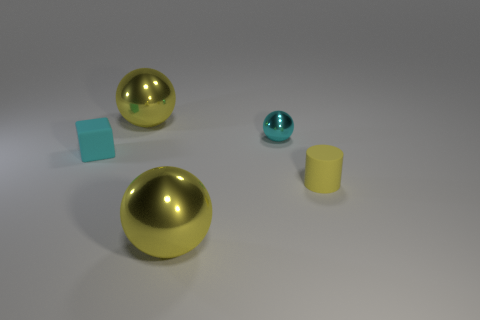Does the small cyan thing right of the tiny cyan matte object have the same shape as the big yellow object that is in front of the tiny cyan matte block?
Offer a very short reply. Yes. How many matte objects are the same color as the tiny metal thing?
Offer a very short reply. 1. What shape is the small object that is left of the large yellow sphere behind the cyan block?
Make the answer very short. Cube. What number of brown objects are either small matte cylinders or matte cubes?
Make the answer very short. 0. What color is the small metal ball?
Your response must be concise. Cyan. Does the cube have the same size as the yellow cylinder?
Your response must be concise. Yes. Is there anything else that is the same shape as the tiny yellow object?
Your response must be concise. No. Is the tiny cube made of the same material as the big yellow sphere behind the rubber cylinder?
Provide a succinct answer. No. There is a large sphere that is behind the tiny matte cube; does it have the same color as the small ball?
Your answer should be compact. No. What number of yellow objects are in front of the small cyan rubber block and to the left of the small yellow matte cylinder?
Your answer should be compact. 1. 